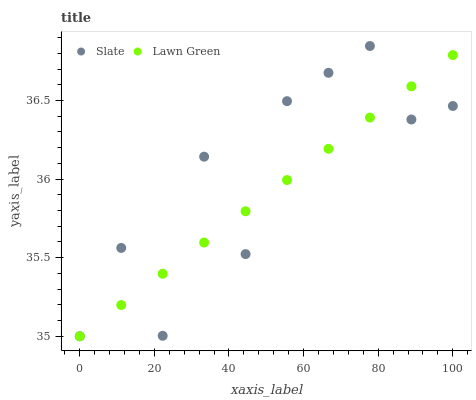Does Lawn Green have the minimum area under the curve?
Answer yes or no. Yes. Does Slate have the maximum area under the curve?
Answer yes or no. Yes. Does Slate have the minimum area under the curve?
Answer yes or no. No. Is Lawn Green the smoothest?
Answer yes or no. Yes. Is Slate the roughest?
Answer yes or no. Yes. Is Slate the smoothest?
Answer yes or no. No. Does Lawn Green have the lowest value?
Answer yes or no. Yes. Does Slate have the highest value?
Answer yes or no. Yes. Does Slate intersect Lawn Green?
Answer yes or no. Yes. Is Slate less than Lawn Green?
Answer yes or no. No. Is Slate greater than Lawn Green?
Answer yes or no. No. 